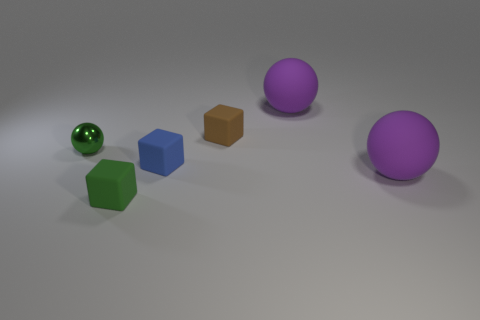Add 2 green things. How many objects exist? 8 Subtract all tiny red matte spheres. Subtract all blue cubes. How many objects are left? 5 Add 6 tiny blue rubber things. How many tiny blue rubber things are left? 7 Add 3 large red blocks. How many large red blocks exist? 3 Subtract 0 yellow cubes. How many objects are left? 6 